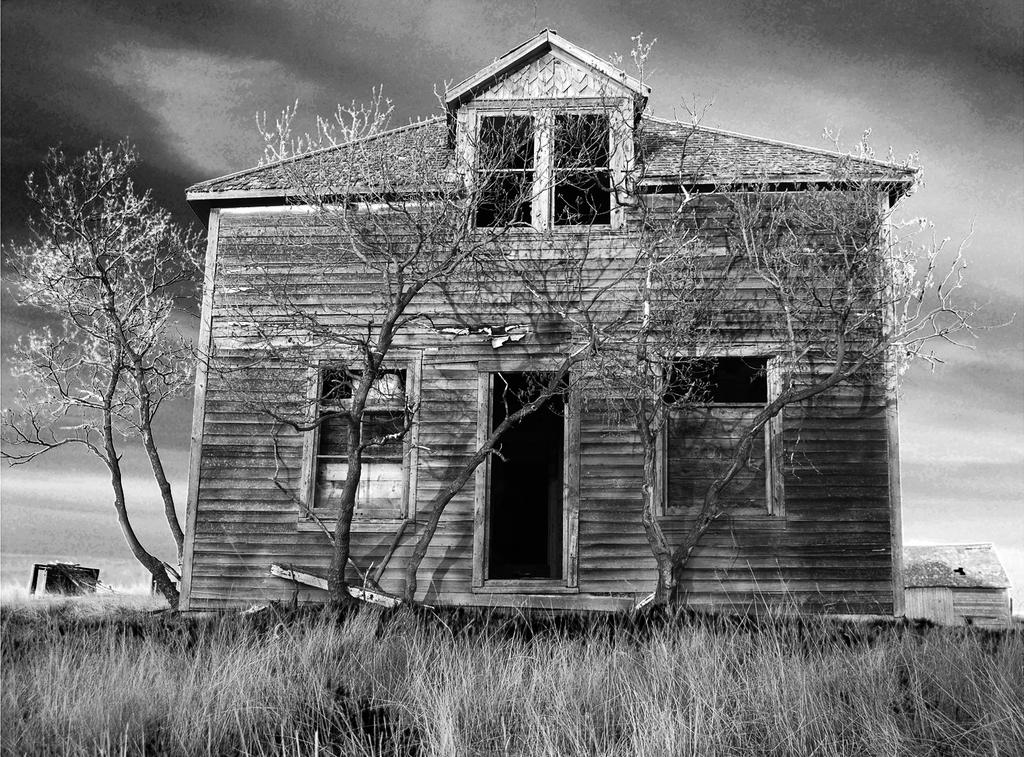What type of vegetation is in the foreground of the image? There is grass in the foreground of the image. What structure is located in the middle of the image? There is a house in the middle of the image. What other natural elements can be seen in the image? There are trees visible in the image. What type of sugar is being used to draw on the chalkboard in the image? There is no chalkboard or sugar present in the image. What is the best way to reach the house in the image? The image does not provide information about the location or accessibility of the house, so it is not possible to determine the best way to reach it. 